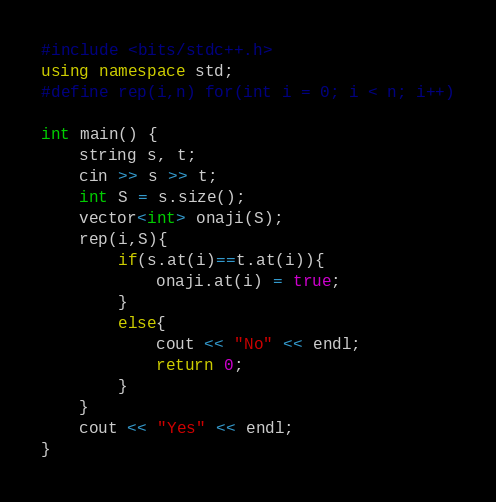<code> <loc_0><loc_0><loc_500><loc_500><_C++_>#include <bits/stdc++.h>
using namespace std;
#define rep(i,n) for(int i = 0; i < n; i++)

int main() {
    string s, t;
    cin >> s >> t;
    int S = s.size();
    vector<int> onaji(S);
    rep(i,S){
        if(s.at(i)==t.at(i)){
            onaji.at(i) = true;
        }
        else{
            cout << "No" << endl;
            return 0;
        }
    }
    cout << "Yes" << endl;
}
</code> 